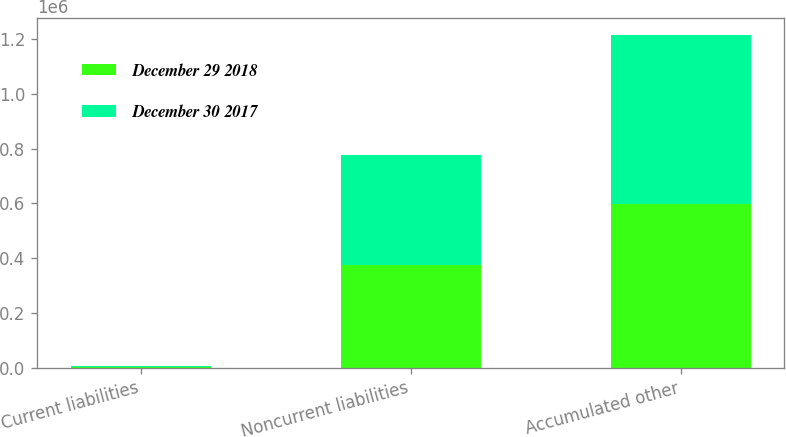Convert chart to OTSL. <chart><loc_0><loc_0><loc_500><loc_500><stacked_bar_chart><ecel><fcel>Current liabilities<fcel>Noncurrent liabilities<fcel>Accumulated other<nl><fcel>December 29 2018<fcel>3765<fcel>374615<fcel>597457<nl><fcel>December 30 2017<fcel>3663<fcel>401749<fcel>618416<nl></chart> 